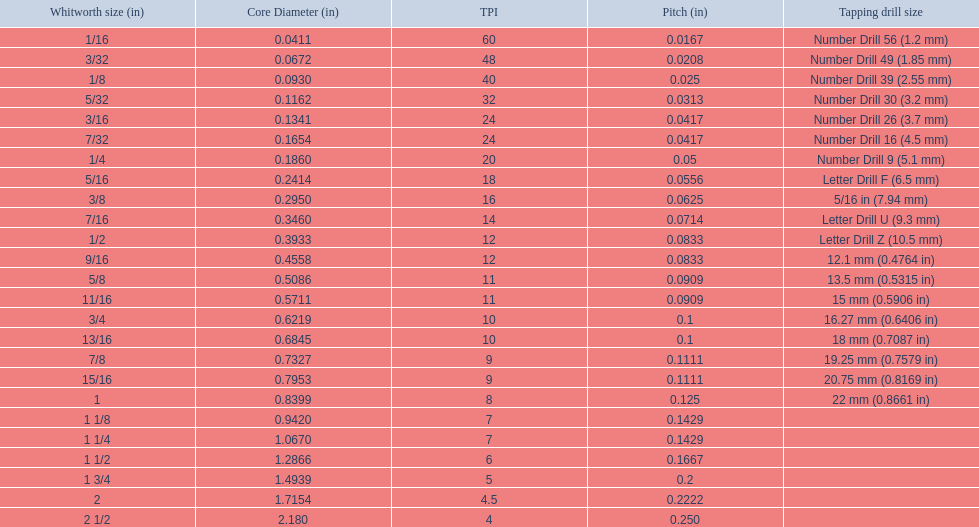Which whitworth size has the same number of threads per inch as 3/16? 7/32. 